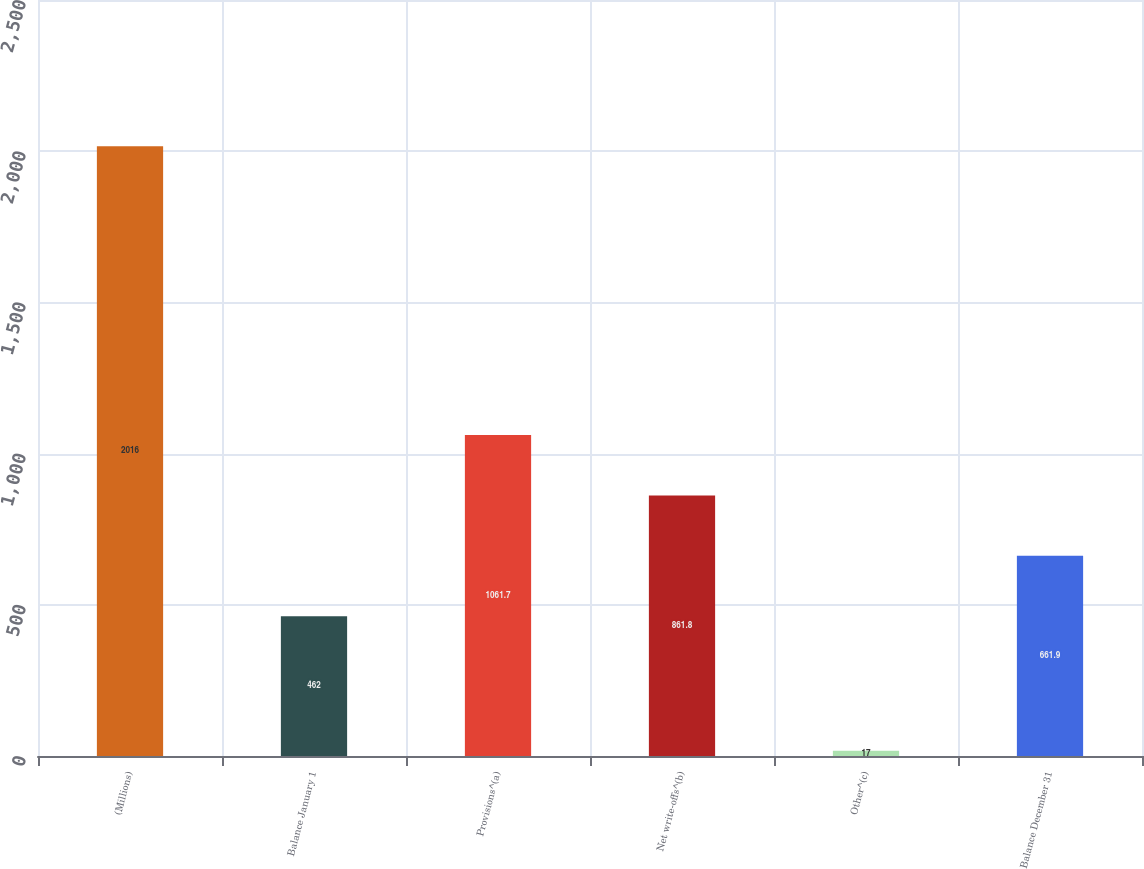<chart> <loc_0><loc_0><loc_500><loc_500><bar_chart><fcel>(Millions)<fcel>Balance January 1<fcel>Provisions^(a)<fcel>Net write-offs^(b)<fcel>Other^(c)<fcel>Balance December 31<nl><fcel>2016<fcel>462<fcel>1061.7<fcel>861.8<fcel>17<fcel>661.9<nl></chart> 